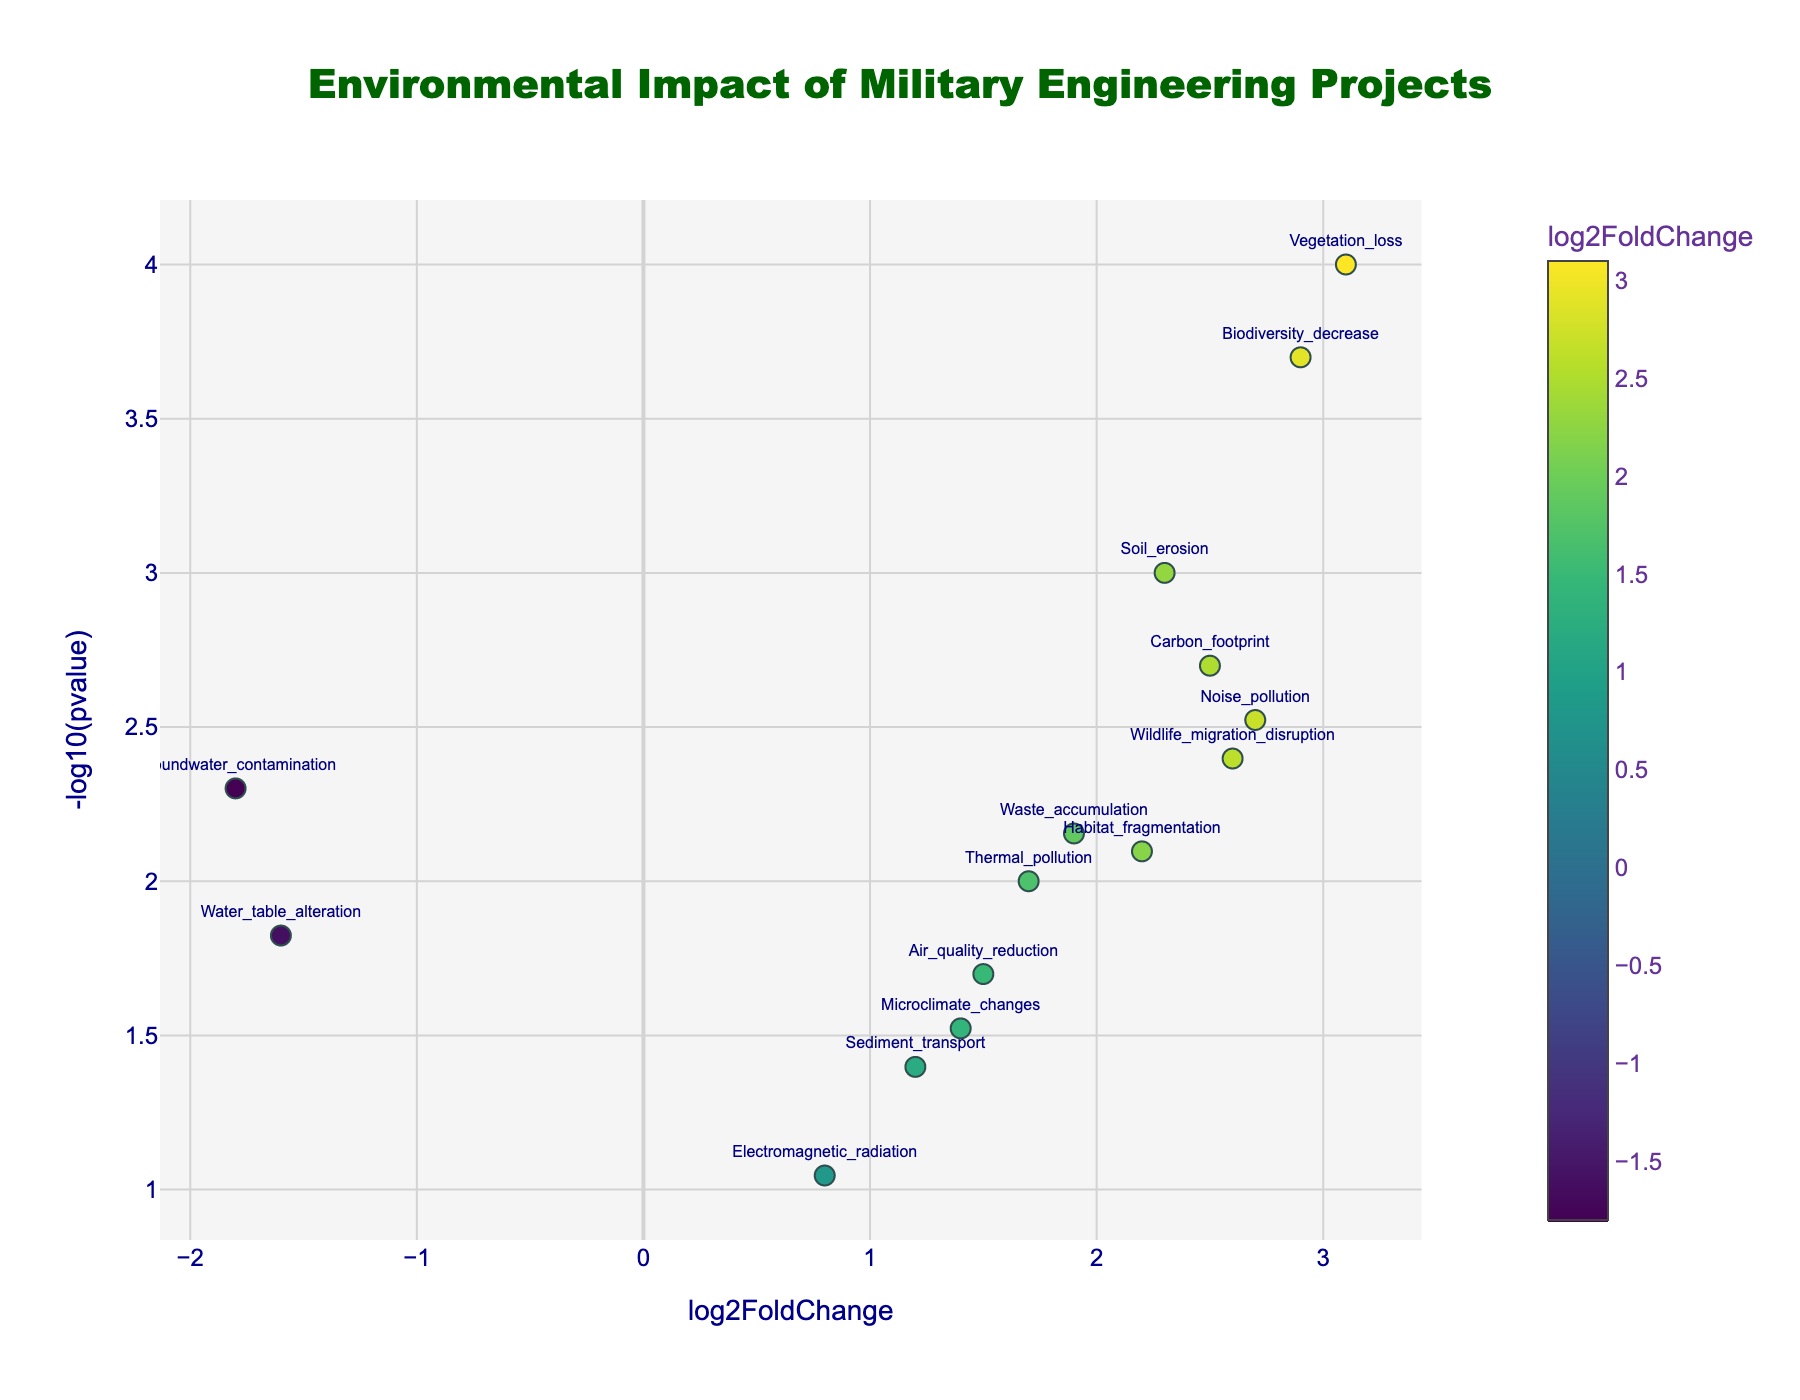What is the title of the plot? The title of the plot is displayed at the top and is usually more prominent than other text elements. Here, the title reads "Environmental Impact of Military Engineering Projects" as per the given code.
Answer: Environmental Impact of Military Engineering Projects Which data point has the highest -log10(pvalue)? To find the data point with the highest -log10(pvalue), look for the point with the highest y-value. According to the data, "Vegetation_loss" has the smallest p-value (0.0001), hence the highest -log10(pvalue).
Answer: Vegetation_loss What is the x-axis label? The label for the x-axis is written beneath the horizontal axis of the plot. From the given code, the label is "log2FoldChange".
Answer: log2FoldChange Which data point has the highest log2FoldChange and what is its value? To identify the point with the highest log2FoldChange, locate the right-most point on the x-axis. According to the data, "Vegetation_loss" has the highest log2FoldChange of 3.1.
Answer: Vegetation_loss, 3.1 How many data points have a log2FoldChange greater than 2.0? Count the number of points that are positioned to the right of the 2.0 mark on the x-axis. From the data, these points are "Soil_erosion," "Vegetation_loss," "Noise_pollution," "Biodiversity_decrease," "Carbon_footprint," and "Wildlife_migration_disruption," totaling 6.
Answer: 6 Which data point has the lowest log2FoldChange and what is its value? The data point with the lowest log2FoldChange will be the leftmost on the x-axis. According to the data, "Groundwater_contamination" has the lowest log2FoldChange of -1.8.
Answer: Groundwater_contamination, -1.8 Compare "Soil_erosion" and "Noise_pollution". Which one has a higher p-value and what are their respective values? Compare the p-values (the y-axis values inversely as -log10(pvalue)). "Soil_erosion" has a p-value of 0.001 and "Noise_pollution" has a p-value of 0.003. The point with a lower -log10(pvalue) (i.e., higher p-value) signifies a higher p-value. Thus, "Noise_pollution" has a higher p-value.
Answer: Noise_pollution, (Soil_erosion: 0.001, Noise_pollution: 0.003) Which data points have both a log2FoldChange above 1.5 and -log10(pvalue) above 2.0? Look for points where x > 1.5 and y > 2.0. From the data, these points are "Soil_erosion," "Vegetation_loss," "Noise_pollution," "Biodiversity_decrease," "Carbon_footprint," "Wildlife_migration_disruption," lying within the specified thresholds.
Answer: Soil_erosion, Vegetation_loss, Noise_pollution, Biodiversity_decrease, Carbon_footprint, Wildlife_migration_disruption What is the y-axis title? The title for the y-axis is written along the vertical axis of the plot. According to the given code, the label is "-log10(pvalue)".
Answer: -log10(pvalue) Which data point might be considered the least significant in terms of environmental impact given the plot? The least significant point will have the lowest -log10(pvalue) (smallest y-value) and lower log2FoldChange (closer to the origin). "Electromagnetic_radiation" has the lowest -log10(pvalue) among given data points based on 0.09 p-value, making it the least significant.
Answer: Electromagnetic_radiation 